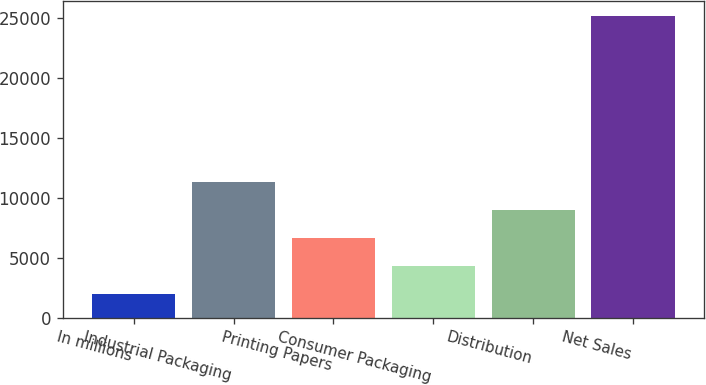<chart> <loc_0><loc_0><loc_500><loc_500><bar_chart><fcel>In millions<fcel>Industrial Packaging<fcel>Printing Papers<fcel>Consumer Packaging<fcel>Distribution<fcel>Net Sales<nl><fcel>2010<fcel>11277.6<fcel>6643.8<fcel>4326.9<fcel>8960.7<fcel>25179<nl></chart> 